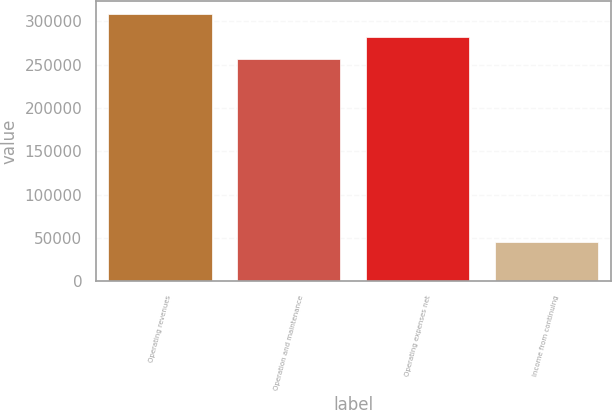Convert chart to OTSL. <chart><loc_0><loc_0><loc_500><loc_500><bar_chart><fcel>Operating revenues<fcel>Operation and maintenance<fcel>Operating expenses net<fcel>Income from continuing<nl><fcel>308752<fcel>256268<fcel>282510<fcel>44948<nl></chart> 